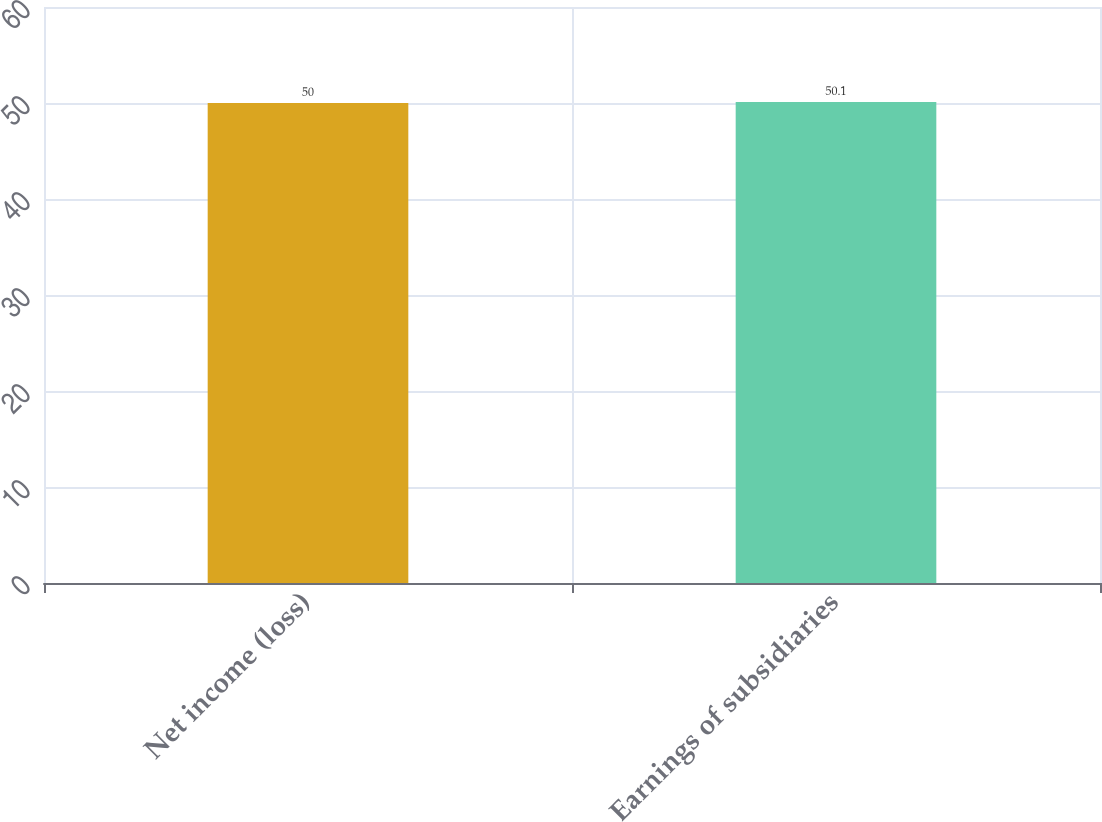<chart> <loc_0><loc_0><loc_500><loc_500><bar_chart><fcel>Net income (loss)<fcel>Earnings of subsidiaries<nl><fcel>50<fcel>50.1<nl></chart> 